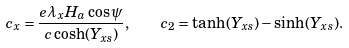Convert formula to latex. <formula><loc_0><loc_0><loc_500><loc_500>c _ { x } = \frac { { e } \lambda _ { x } H _ { a } \cos \psi } { c \cosh ( Y _ { x s } ) } , \quad c _ { 2 } = \tanh ( Y _ { x s } ) - \sinh ( Y _ { x s } ) .</formula> 